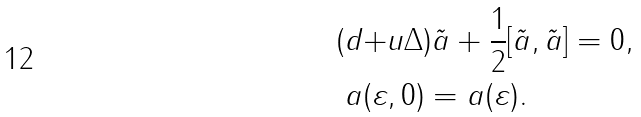Convert formula to latex. <formula><loc_0><loc_0><loc_500><loc_500>( d + & u \Delta ) \tilde { a } + \frac { 1 } { 2 } [ \tilde { a } , \tilde { a } ] = 0 , \\ a ( \varepsilon & , 0 ) = a ( \varepsilon ) .</formula> 